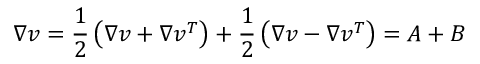Convert formula to latex. <formula><loc_0><loc_0><loc_500><loc_500>\nabla v = \frac { 1 } { 2 } \left ( { \nabla v + \nabla v ^ { T } } \right ) + \frac { 1 } { 2 } \left ( { \nabla v - \nabla v ^ { T } } \right ) = A + B</formula> 